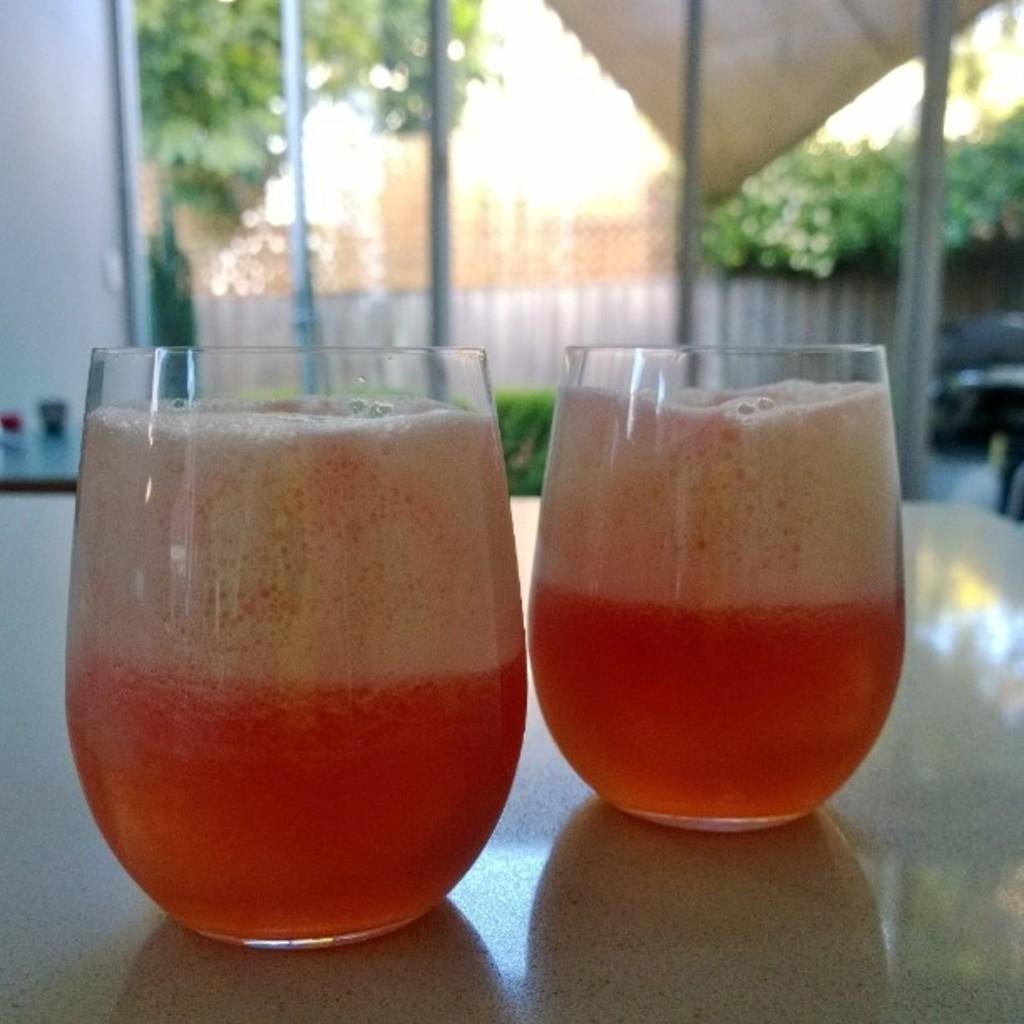What objects are on the table in the foreground of the image? There are two juice glasses on a table in the foreground. What can be seen in the background of the image? In the background, there are plants, pillars, a fence, a cat, trees, and the sky. What type of establishment is the image taken in? The image is taken in a hotel. What activity is the sun participating in with the cat in the background? There is no sun present in the image, and therefore no activity involving the sun can be observed. 